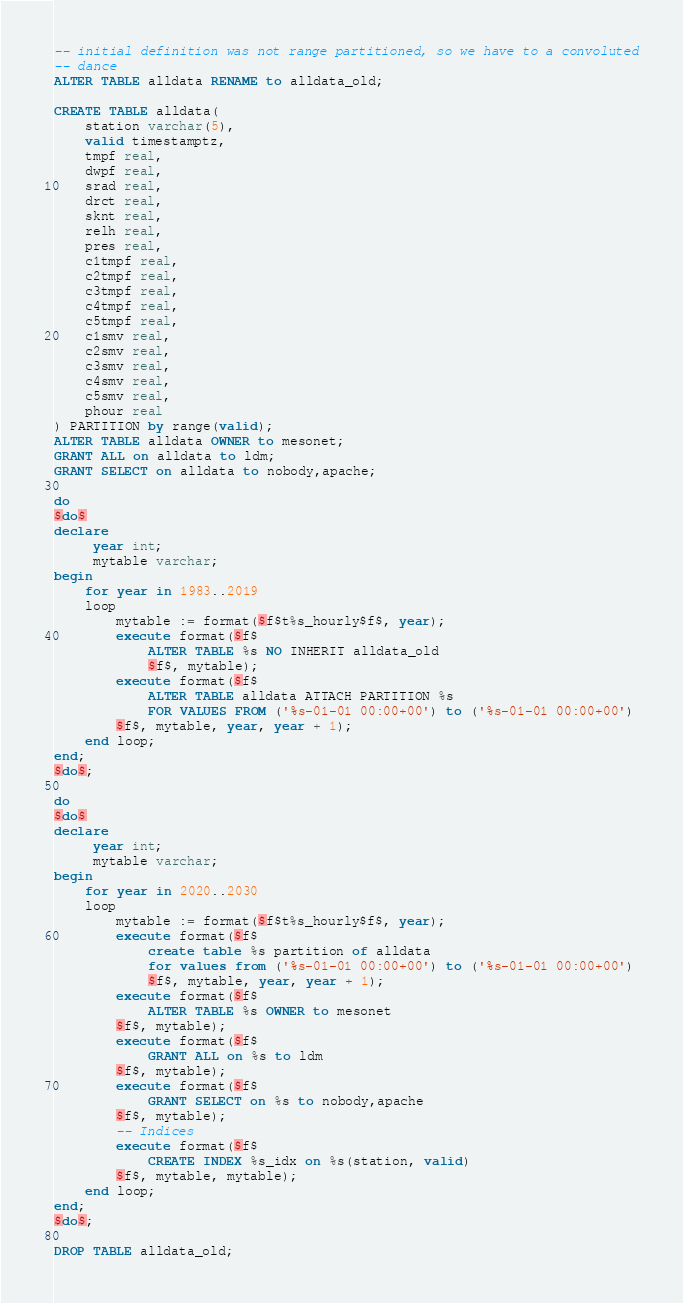<code> <loc_0><loc_0><loc_500><loc_500><_SQL_>-- initial definition was not range partitioned, so we have to a convoluted
-- dance
ALTER TABLE alldata RENAME to alldata_old;

CREATE TABLE alldata(
	station varchar(5),
	valid timestamptz,
	tmpf real,
	dwpf real,
	srad real,
	drct real,
	sknt real,
	relh real,
	pres real,
	c1tmpf real,
	c2tmpf real,
	c3tmpf real,
	c4tmpf real,
	c5tmpf real,
	c1smv real,
	c2smv real,
	c3smv real,
	c4smv real,
	c5smv real,
	phour real
) PARTITION by range(valid);
ALTER TABLE alldata OWNER to mesonet;
GRANT ALL on alldata to ldm;
GRANT SELECT on alldata to nobody,apache;

do
$do$
declare
     year int;
     mytable varchar;
begin
    for year in 1983..2019
    loop
        mytable := format($f$t%s_hourly$f$, year);
        execute format($f$
            ALTER TABLE %s NO INHERIT alldata_old
            $f$, mytable);
        execute format($f$
            ALTER TABLE alldata ATTACH PARTITION %s
            FOR VALUES FROM ('%s-01-01 00:00+00') to ('%s-01-01 00:00+00')
        $f$, mytable, year, year + 1);
    end loop;
end;
$do$;

do
$do$
declare
     year int;
     mytable varchar;
begin
    for year in 2020..2030
    loop
        mytable := format($f$t%s_hourly$f$, year);
        execute format($f$
            create table %s partition of alldata
            for values from ('%s-01-01 00:00+00') to ('%s-01-01 00:00+00')
            $f$, mytable, year, year + 1);
        execute format($f$
            ALTER TABLE %s OWNER to mesonet
        $f$, mytable);
        execute format($f$
            GRANT ALL on %s to ldm
        $f$, mytable);
        execute format($f$
            GRANT SELECT on %s to nobody,apache
        $f$, mytable);
        -- Indices
        execute format($f$
            CREATE INDEX %s_idx on %s(station, valid)
        $f$, mytable, mytable);
    end loop;
end;
$do$;

DROP TABLE alldata_old;
</code> 